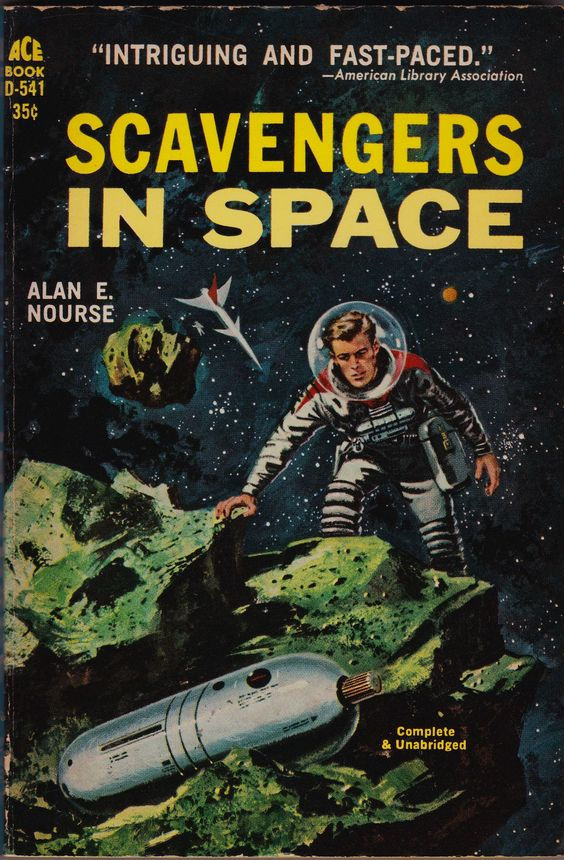describe esta imagen con todo lujo de detalles
 La imagen muestra la portada de un libro titulado "Scavengers in Space" por Alan E. Nourse. La portada tiene un diseño clásico de ciencia ficción del siglo XX.

**Descripción detallada:**

- **Texto en la parte superior:**
  - En la esquina superior izquierda, en letras amarillas, se lee "ACE BOOK D-541".
  - Justo debajo, también en amarillo, está el precio "35¢".
  - En la parte superior central, hay una cita en letras blancas: "INTRIGUING AND FAST-PACED." seguida de "-American Library Association".

- **Título:**
  - El título "SCAVENGERS IN SPACE" está en letras grandes y amarillas en el centro de la portada. La palabra "SCAVENGERS" está en la parte superior y "IN SPACE" justo debajo.

- **Autor:**
  - A la izquierda del título, en letras blancas más pequeñas, se lee "ALAN E. NOURSE".

- **Ilustración:**
  - La ilustración muestra a un astronauta en un traje espacial clásico, completo con un casco redondo transparente. El astronauta es un hombre de cabello claro que parece estar explorando una superficie rocosa.
  - El astronauta está en una postura inclinada, con una mano tocando una roca verde y la otra sosteniendo lo que parece ser un dispositivo o herramienta.
  - La escena ocurre en el espacio exterior, con un fondo estrellado y oscuro.
  - Hay asteroides o rocas espaciales flotando alrededor.
  - En la parte superior izquierda, cerca del astronauta, hay una nave espacial pequeña y puntiaguda volando.
  - En la parte inferior de la ilustración, se ve una cápsula espacial plateada, parcialmente enterrada en las rocas verdes.

- **Texto adicional:**
  - En la esquina inferior derecha, en letras amarillas, se lee "Complete & Unabridged".

La portada logra transmitir una sensación de aventura y exploración espacial, típica de las novelas de ciencia ficción de la época. with this description write in english a complete stable diffusion prompt to really portray the image: ""La imagen muestra la portada de un libro titulado "Scavengers in Space" por Alan E. Nourse. La portada tiene un diseño clásico de ciencia ficción del siglo XX.

Descripción detallada:

Texto en la parte superior:

En la esquina superior izquierda, en letras amarillas, se lee "ACE BOOK D-541".
Justo debajo, también en amarillo, está el precio "35¢".
En la parte superior central, hay una cita en letras blancas: "INTRIGUING AND FAST-PACED." seguida de "-American Library Association".
Título:

El título "SCAVENGERS IN SPACE" está en letras grandes y amarillas en el centro de la portada. La palabra "SCAVENGERS" está en la parte superior y "IN SPACE" justo debajo.
Autor:

A la izquierda del título, en letras blancas más pequeñas, se lee "ALAN E. NOURSE".
Ilustración:

La ilustración muestra a un astronauta en un traje espacial clásico, completo con un casco redondo transparente. El astronauta es un hombre de cabello claro que parece estar explorando una superficie rocosa.
El astronauta está en una postura inclinada, con una mano tocando una roca verde y la otra sosteniendo lo que parece ser un dispositivo o herramienta.
La escena ocurre en el espacio exterior, con un fondo estrellado y oscuro.
Hay asteroides o rocas espaciales flotando alrededor.
En la parte superior izquierda, cerca del astronauta, hay una nave espacial pequeña y puntiaguda volando.
En la parte inferior de la ilustración, se ve una cápsula espacial plateada, parcialmente enterrada en las rocas verdes.
Texto adicional:

En la esquina inferior derecha, en letras amarillas, se lee "Complete & Unabridged".
La portada logra transmitir una sensación de aventura y exploración espacial, típica de las novelas de ciencia ficción de la época."" "Create a book cover titled 'Scavengers in Space' by Alan E. Nourse with a classic mid-20th-century science fiction design. 

**Text Details:**
- In the upper left corner, in yellow letters, write 'ACE BOOK D-541'.
- Just below, also in yellow, place the price '35¢'.
- In the top center, add a white quote: 'INTRIGUING AND FAST-PACED.' followed by '-American Library Association'.
- The main title 'SCAVENGERS IN SPACE' should be in large yellow letters in the center of the cover. The word 'SCAVENGERS' at the top and 'IN SPACE' just below.
- To the left of the title, in smaller white letters, add 'ALAN E. NOURSE'.
- In the bottom right corner, in yellow letters, write 'Complete & Unabridged'.

**Illustration Details:**
- Show an astronaut in a classic space suit with a clear round helmet. The astronaut should have light-colored hair and be exploring a rocky surface.
- The astronaut is leaning forward, with one hand touching a green rock and the other holding a device or tool.
- The background should depict outer space with a dark, starry sky.
- Include floating asteroids or space rocks.
- In the upper left area, near the astronaut, depict a small, pointed spaceship flying.
- In the bottom of the illustration, show a silver space capsule partially buried in green rocks.

The cover should convey a sense of adventure and space exploration typical of science fiction novels from that era." 